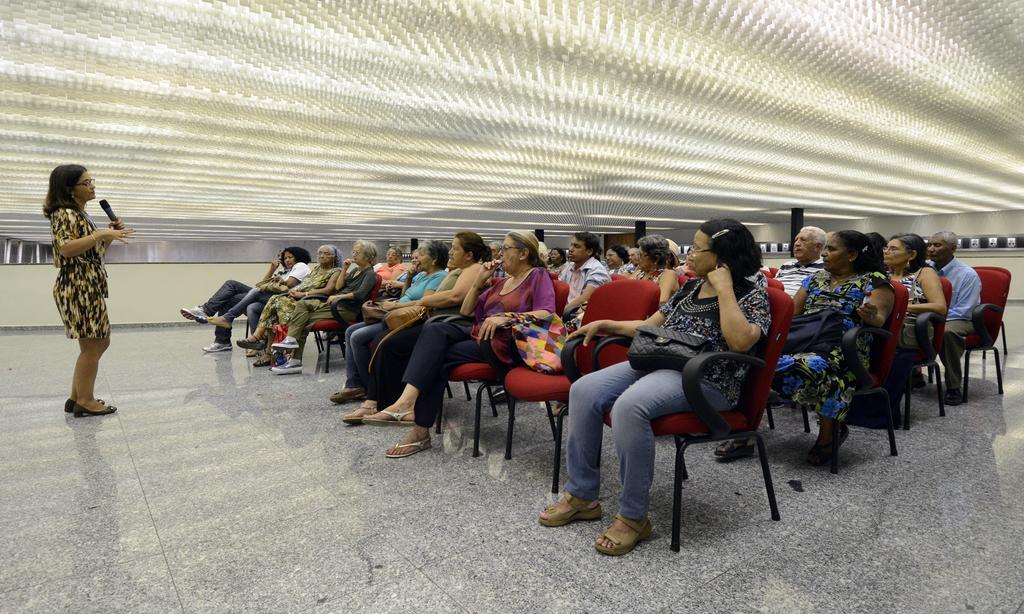How would you summarize this image in a sentence or two? In this image we can see a group of people sitting and hearing to the lecture. And the top of image is white roofing. 